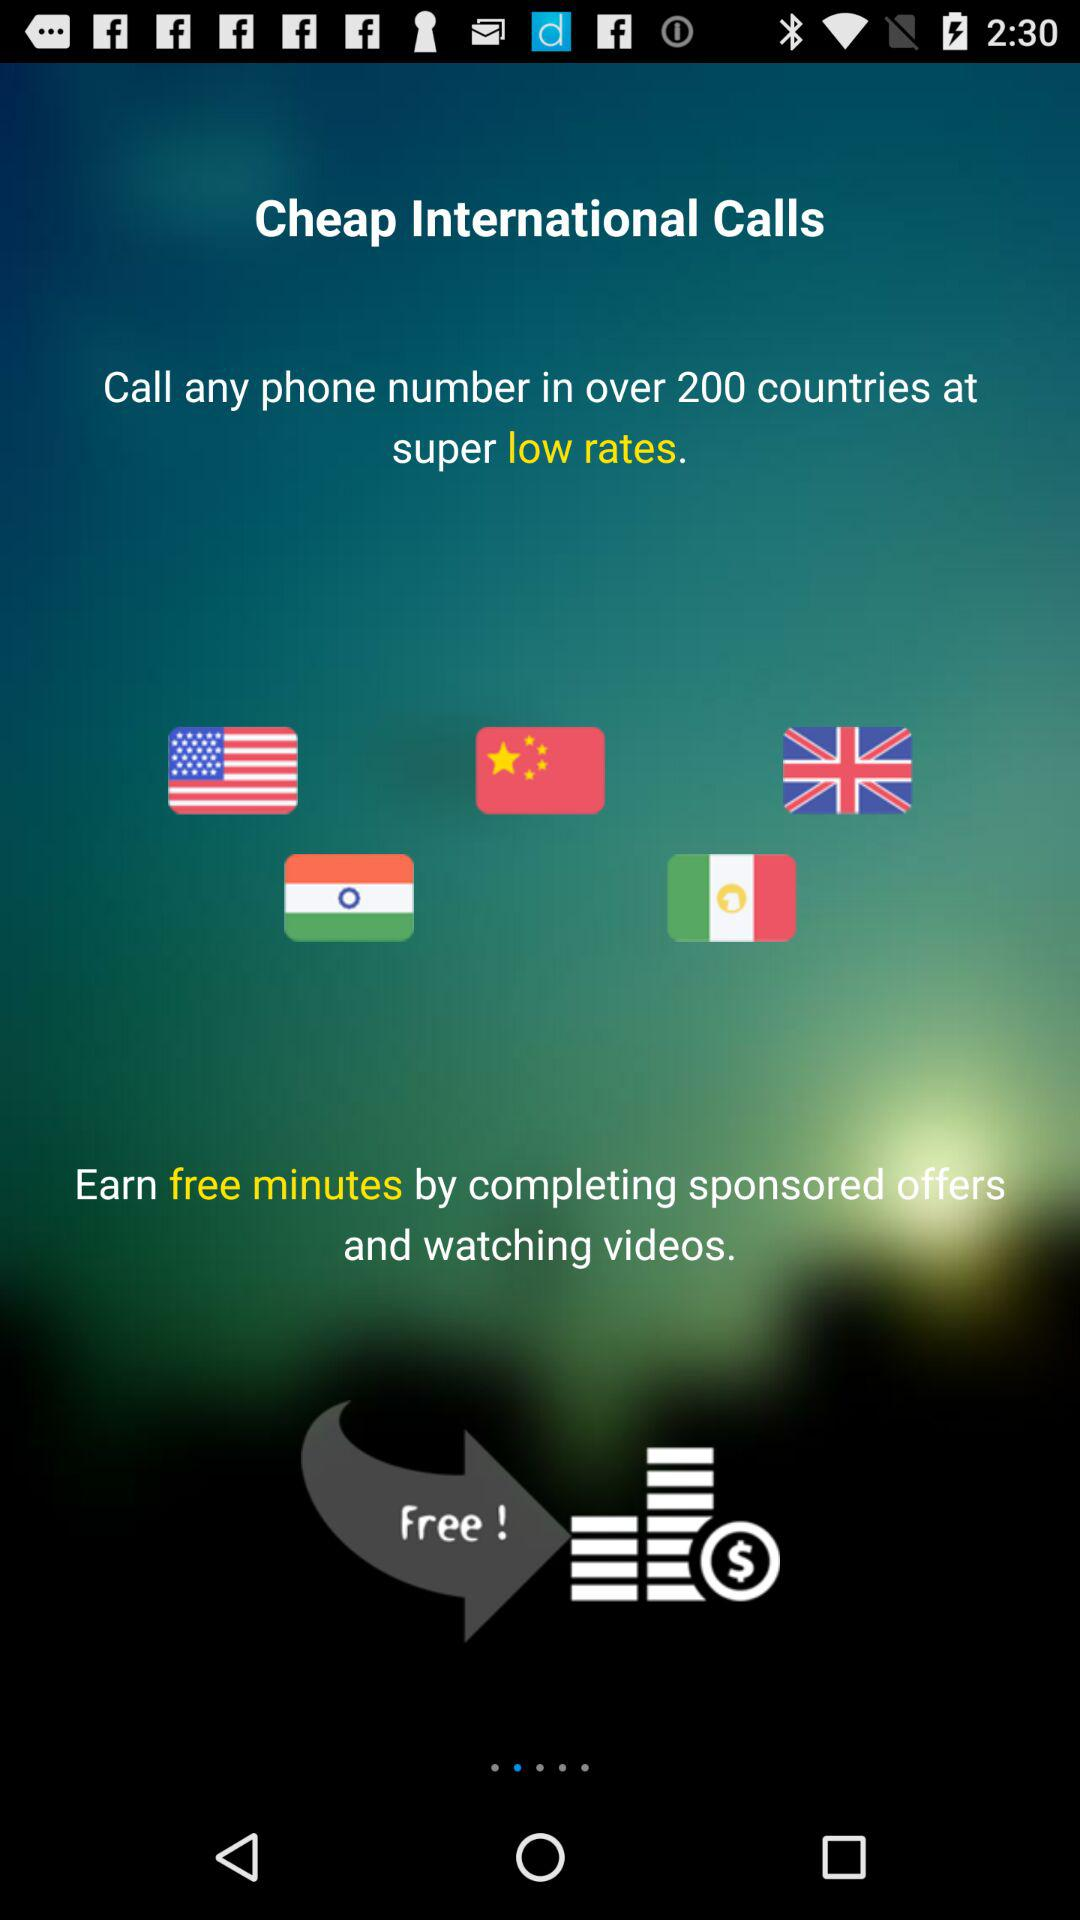How can free minutes be earned? Free minutes can be earned by completing sponsored offers and watching videos. 